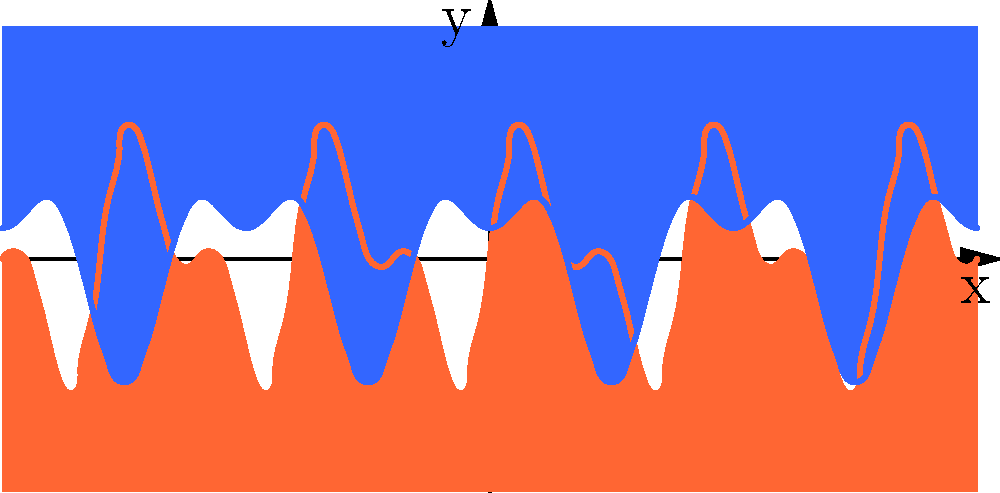In the abstract painting represented by the graph above, warm colors (represented by the red curve) and cool colors (represented by the blue curve) are used. How might the interplay between these color temperatures affect the emotional impact of the artwork, and what artistic techniques could be employed to create a sense of balance or tension using this color scheme? 1. Color Temperature: The red curve represents warm colors (e.g., reds, oranges, yellows), while the blue curve represents cool colors (e.g., blues, greens, purples).

2. Emotional Impact:
   a) Warm colors tend to evoke feelings of energy, excitement, and passion.
   b) Cool colors often convey calmness, serenity, and introspection.

3. Interplay Analysis:
   a) Where the curves intersect, there's a balance between warm and cool.
   b) Areas where one curve dominates suggest a stronger emotional pull in that direction.

4. Artistic Techniques for Balance:
   a) Complementary colors: Use opposite colors on the color wheel to create vibrant contrast.
   b) Color harmony: Employ analogous colors for a more cohesive feel.
   c) Varying saturation: Adjust color intensity to create focal points.

5. Creating Tension:
   a) Juxtaposition: Place warm and cool colors side by side for dramatic effect.
   b) Unexpected color use: Use colors in unconventional ways to challenge viewer expectations.

6. Composition Considerations:
   a) Use the golden ratio or rule of thirds to place color transitions at visually appealing points.
   b) Consider the overall shape formed by color areas to guide the viewer's eye.

7. Emotional Narrative:
   Create a "story" within the painting by guiding the viewer through different emotional states using color transitions.
Answer: Balance through complementary colors and harmony; tension via juxtaposition and unexpected color use; emotional narrative through strategic color placement and transitions. 